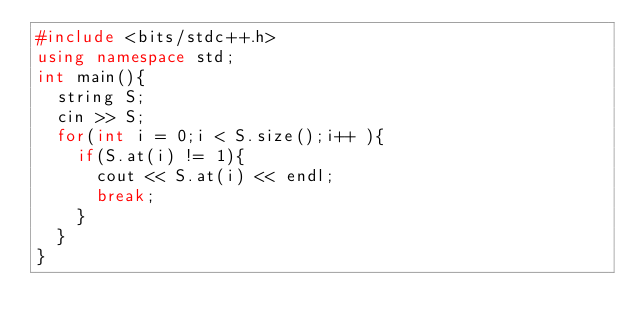<code> <loc_0><loc_0><loc_500><loc_500><_C++_>#include <bits/stdc++.h>
using namespace std;
int main(){
  string S;
  cin >> S;
  for(int i = 0;i < S.size();i++ ){
    if(S.at(i) != 1){
      cout << S.at(i) << endl;
      break;
    }
  }
}   </code> 